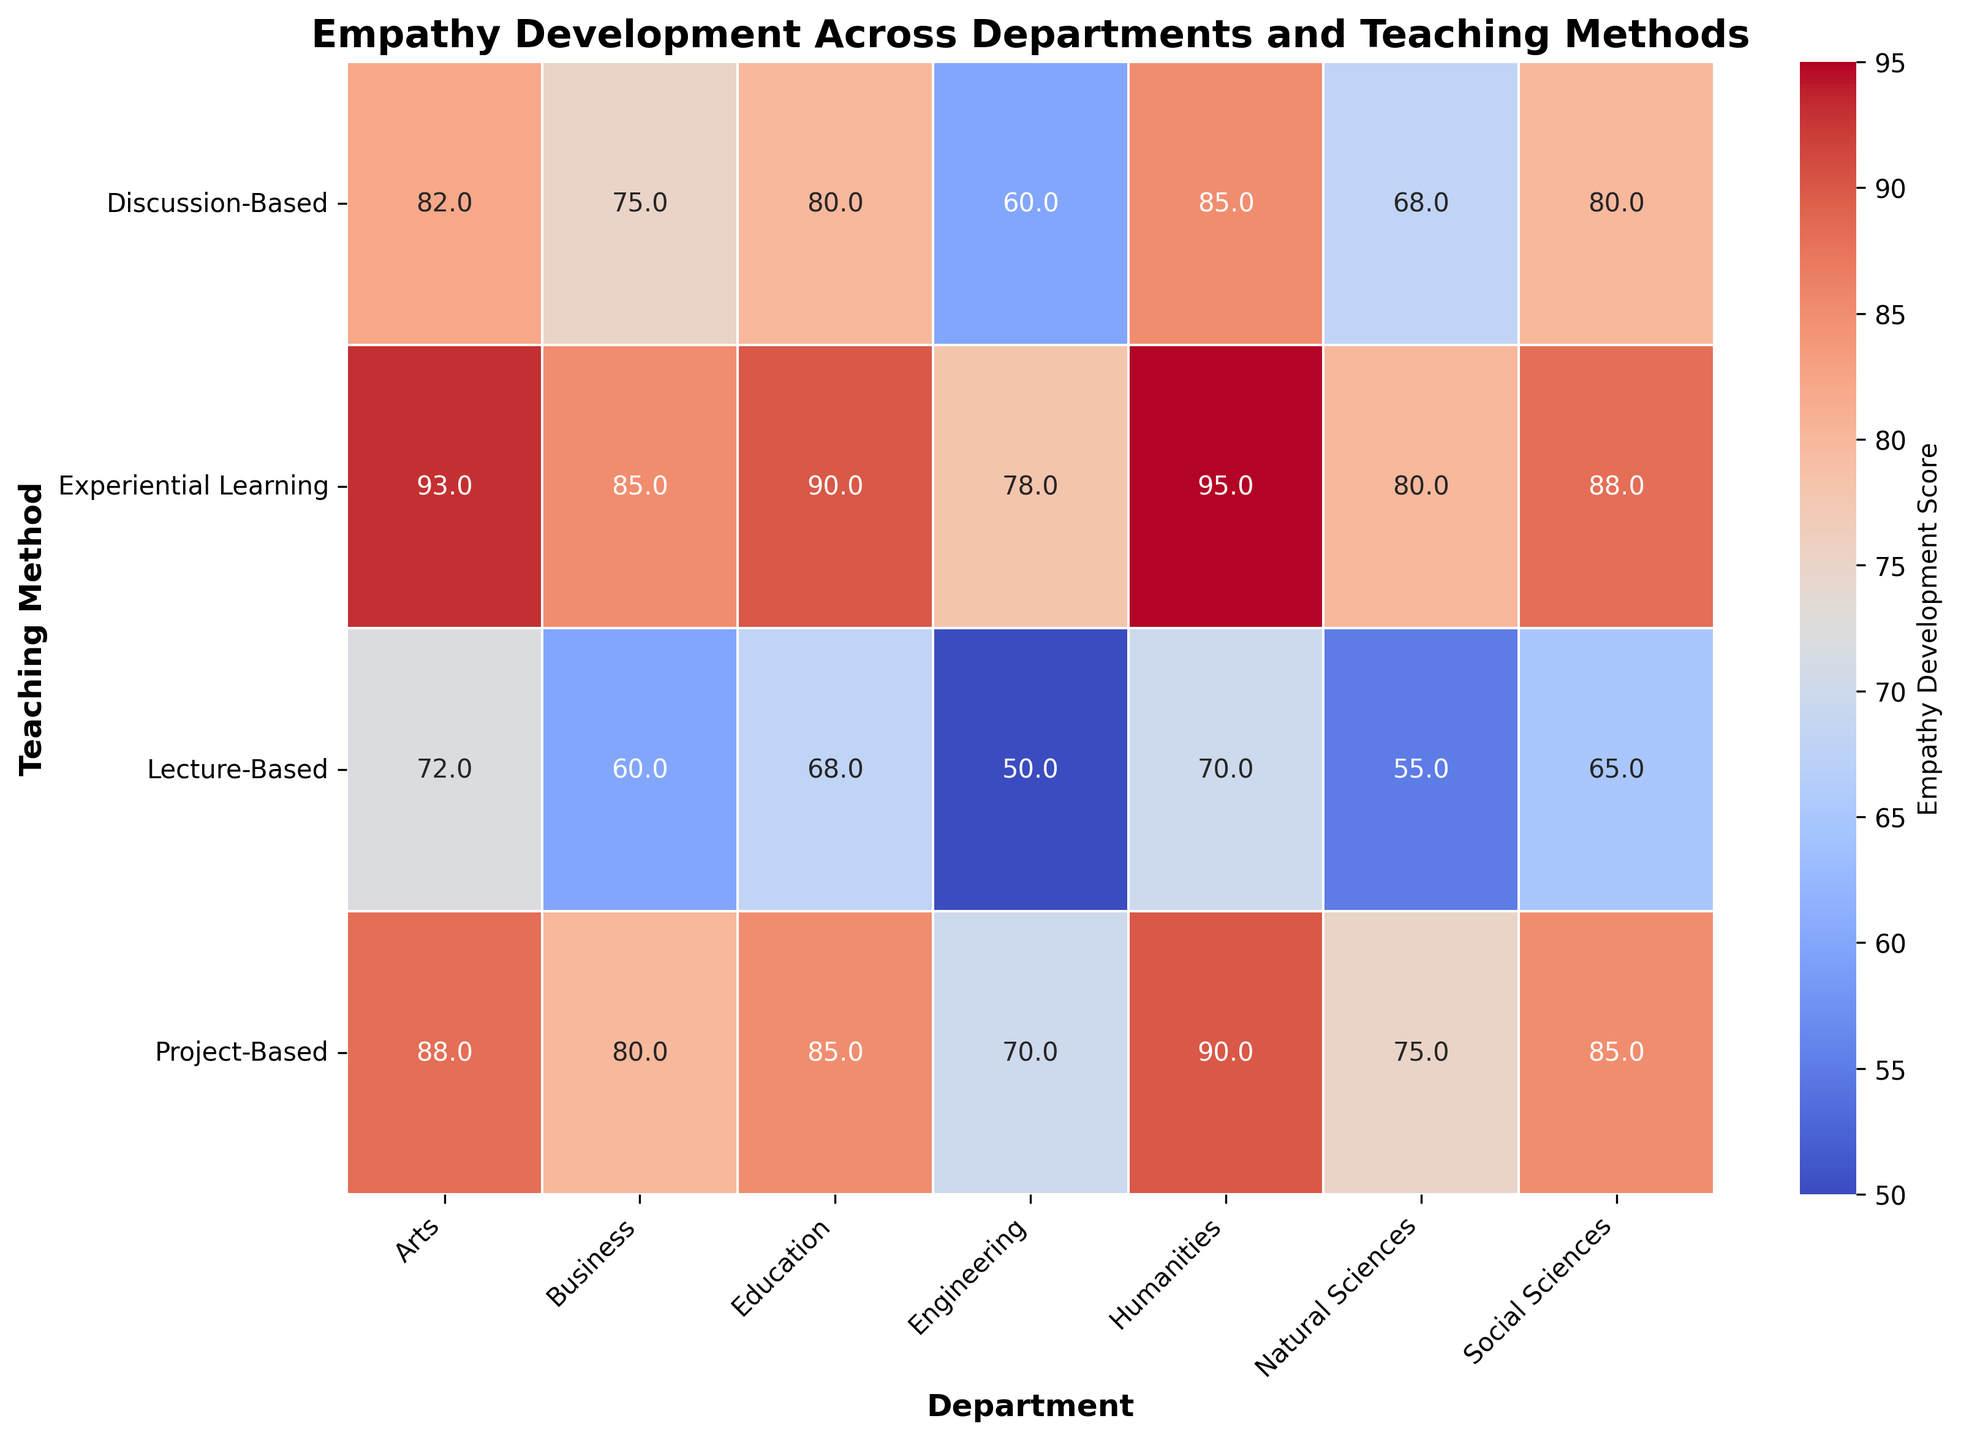Which department shows the highest empathy development score for lecture-based teaching methods? Look at the row corresponding to lecture-based teaching methods and find the highest value in that row. Humanities have the highest score of 70 in the lecture-based teaching method.
Answer: Humanities How do empathy development scores for experiential learning compare between Natural Sciences and Engineering? Refer to the row for experiential learning and compare the scores for Natural Sciences and Engineering. Natural Sciences have a score of 80, and Engineering has a score of 78.
Answer: Natural Sciences have a higher score What is the average empathy development score for discussion-based teaching methods across all departments? Sum up the scores for discussion-based teaching methods across all departments and divide by the number of departments: (85+80+68+60+75+82+80) / 7 = 75.7.
Answer: 75.7 Which combination of department and teaching method has the lowest empathy development score? Scan the entire heatmap to find the lowest value. The lowest score of 50 is found in the Engineering department with lecture-based teaching methods.
Answer: Engineering (Lecture-Based) By how much does the empathy score for project-based teaching in Humanities exceed that in Business? Find the scores for project-based teaching methods in Humanities and Business, then subtract the Business score from the Humanities score: 90 - 80 = 10.
Answer: 10 Out of discussion-based and project-based methods, which has a higher average empathy score across departments? Calculate the average empathy score for both methods: (85+80+68+60+75+82+80)/7 = 75.7 for discussion-based, and (90+85+75+70+80+88+85)/7 = 81.9 for project-based. Compare the averages.
Answer: Project-Based Methods Are there any teaching methods where empathy development scores are equal in two different departments? If yes, specify the teaching method and departments. Scan the heatmap for any equal values within the same row. Project-Based methods show an empathy score of 85 both in Social Sciences and Education.
Answer: Project-Based; Social Sciences and Education Which department shows the greatest increase in empathy development score when switching from lecture-based to experiential learning teaching methods? Calculate the difference (experiential learning score - lecture-based score) for each department and find the greatest increase. Humanities increase by 25 (95-70), the greatest among others.
Answer: Humanities What is the difference between the highest empathy development score and the lowest empathy development score across all teaching methods and departments? Find the highest score (95 in Humanities with experiential learning) and the lowest score (50 in Engineering with lecture-based), then compute the difference: 95 - 50 = 45.
Answer: 45 Which teaching method shows the most consistent empathy development scores across different departments? Look at the variance of scores across all departments for each teaching method. Project-Based (70 to 90) and Experiential Learning (78 to 95) have narrower ranges than Lecture-Based and Discussion-Based. Project-Based is most consistent.
Answer: Project-Based 